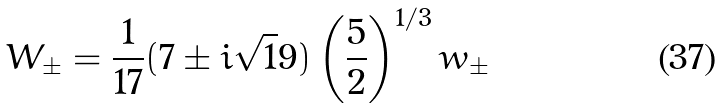<formula> <loc_0><loc_0><loc_500><loc_500>W _ { \pm } = \frac { 1 } { 1 7 } ( 7 \pm i { \sqrt { 1 } 9 } ) \left ( \frac { 5 } { 2 } \right ) ^ { 1 / 3 } w _ { \pm }</formula> 